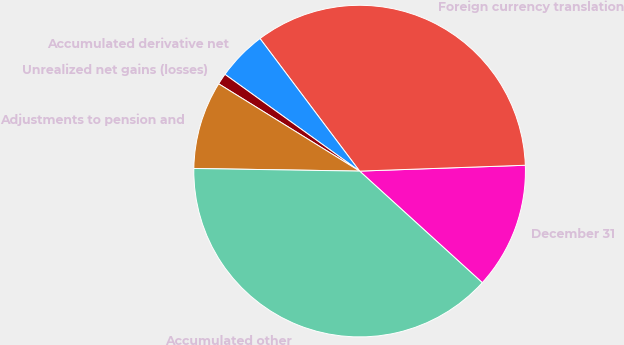<chart> <loc_0><loc_0><loc_500><loc_500><pie_chart><fcel>December 31<fcel>Foreign currency translation<fcel>Accumulated derivative net<fcel>Unrealized net gains (losses)<fcel>Adjustments to pension and<fcel>Accumulated other<nl><fcel>12.31%<fcel>34.69%<fcel>4.83%<fcel>1.09%<fcel>8.57%<fcel>38.5%<nl></chart> 